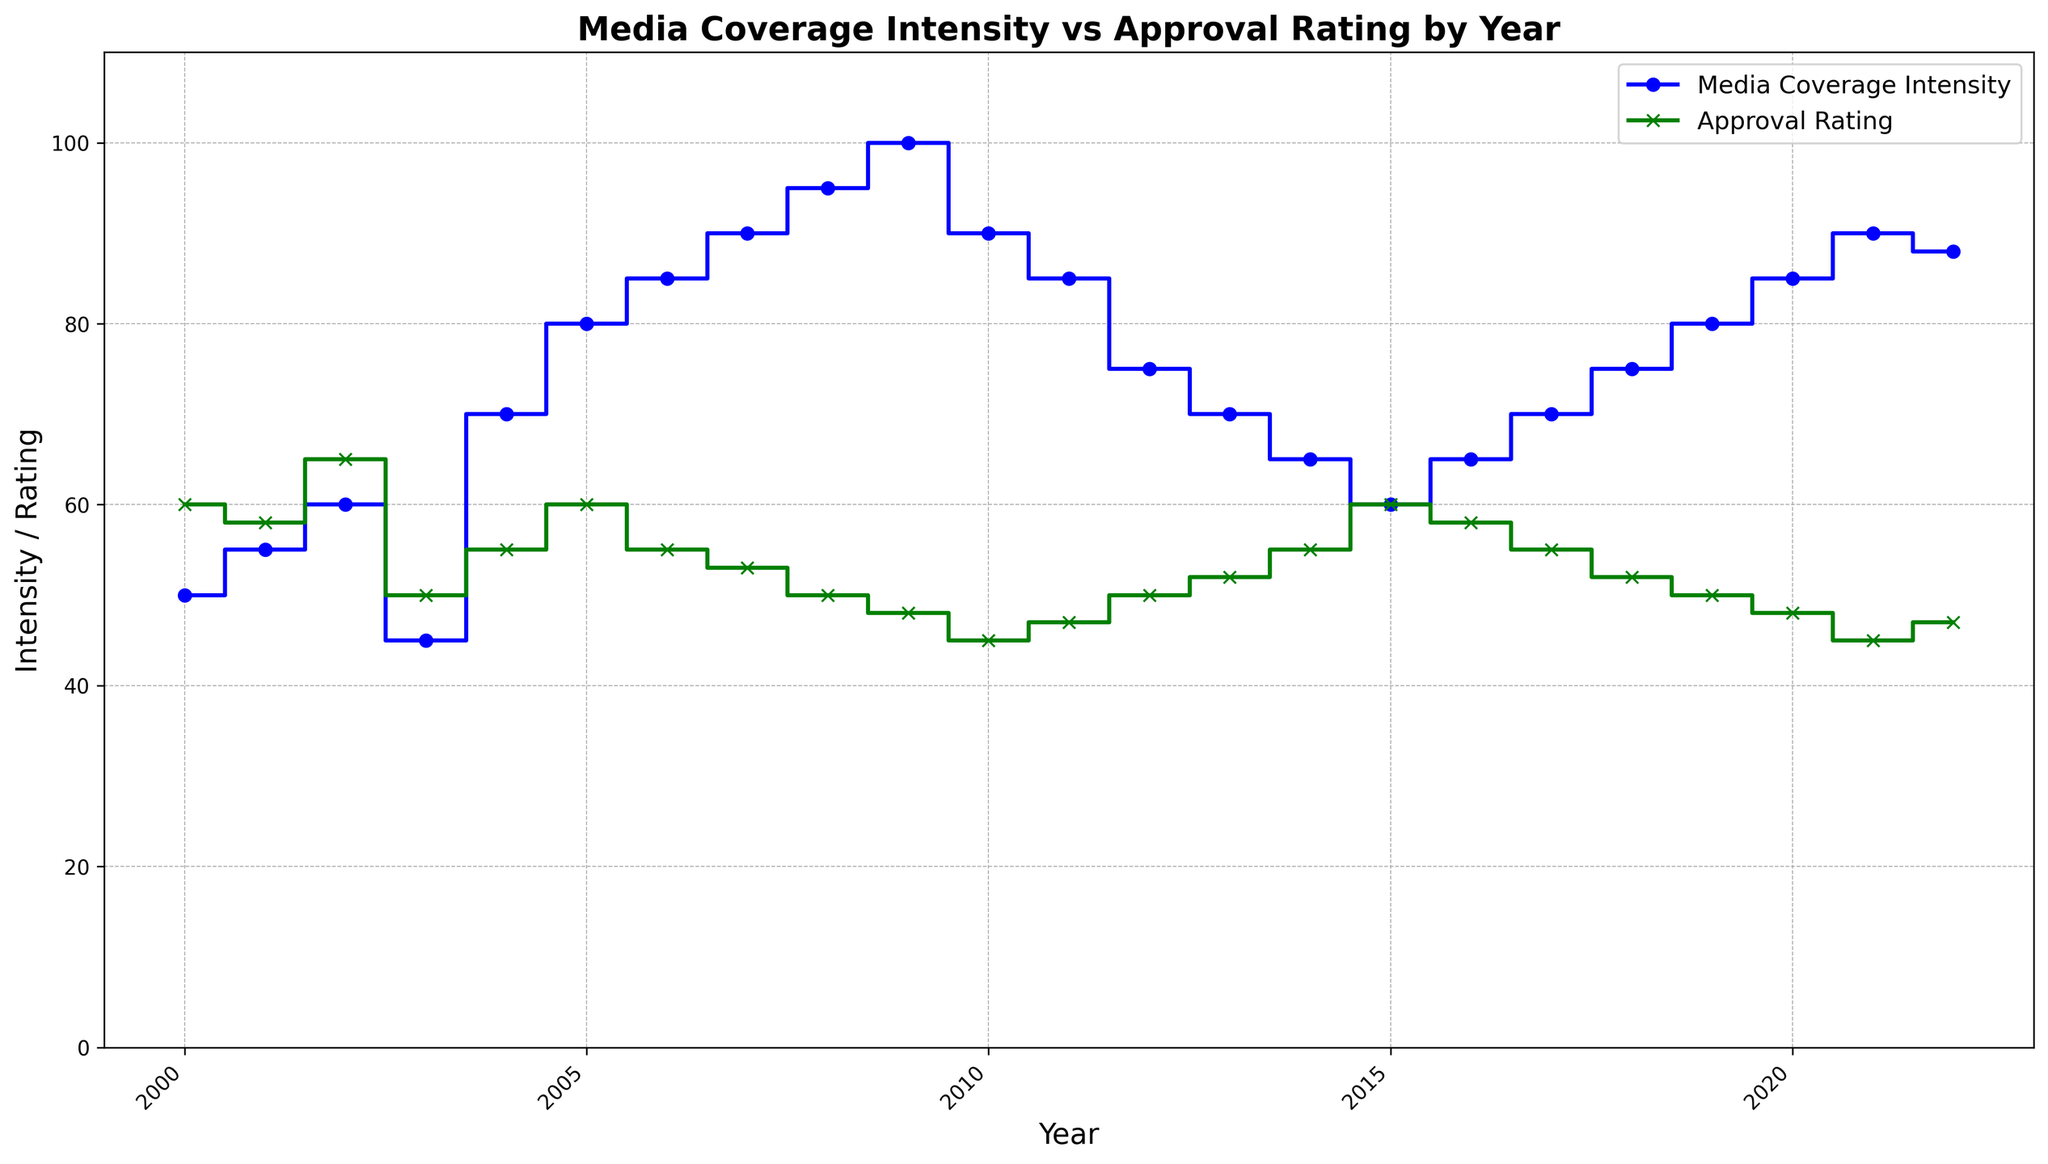What is the highest Media Coverage Intensity value in the plot? The highest value in the Media Coverage Intensity series is found by identifying the maximum y-value of the blue line. The highest value in the plot is 100 in 2009.
Answer: 100 In which year did the Media Coverage Intensity first exceed 90? Observe the blue line and find the year where the Media Coverage Intensity first passes the 90 mark. This happens in 2007.
Answer: 2007 How does the Approval Rating in 2010 compare to that in 2012? Compare the values of the green line for the years 2010 and 2012: In 2010, the Approval Rating is 45, and in 2012, it is 50. Thus, 45 < 50.
Answer: 45 < 50 In what year was there the greatest difference between Media Coverage Intensity and Approval Rating? Calculate the difference for each year, identify the year where this difference is the largest. The differences are highest in 2009: Media Coverage Intensity (100) - Approval Rating (48) = 52.
Answer: 2009 What is the overall trend of Approval Rating from 2009 to 2022? Observe the green line from 2009 to 2022, noting the general direction. The Approval Rating follows a generally decreasing trend, starting from 48 in 2009 and ending at 47 in 2022.
Answer: Generally decreasing Which year shows the smallest gap between Media Coverage Intensity and Approval Rating? Find the year with the smallest difference between the blue and green lines. In 2015, both Media Coverage Intensity and Approval Rating are equal at 60.
Answer: 2015 How many years did Media Coverage Intensity and Approval Rating intersect? Find where the blue and green lines cross each other, indicating intersection points. They intersect once in 2015.
Answer: 1 What is the median Media Coverage Intensity value from 2000 to 2022? List all Media Coverage Intensity values: (50, 55, 60, 45, 70, 80, 85, 90, 95, 100, 90, 85, 75, 70, 65, 60, 65, 70, 75, 80, 85, 90, 88). There are 23 values, so the median is the 12th value (when sorted), which is 75.
Answer: 75 